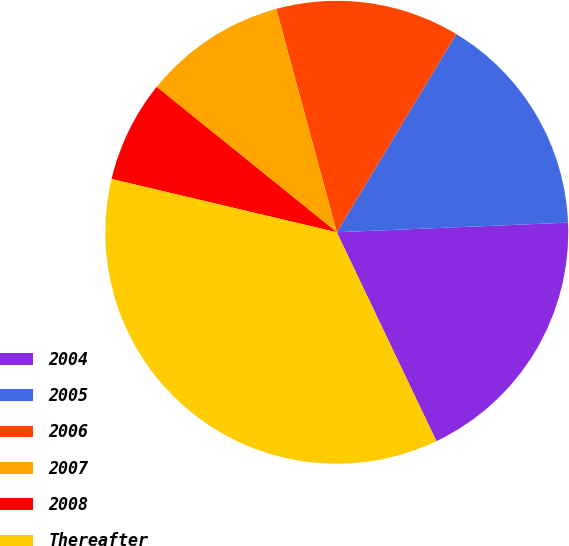<chart> <loc_0><loc_0><loc_500><loc_500><pie_chart><fcel>2004<fcel>2005<fcel>2006<fcel>2007<fcel>2008<fcel>Thereafter<nl><fcel>18.58%<fcel>15.71%<fcel>12.84%<fcel>9.98%<fcel>7.11%<fcel>35.78%<nl></chart> 